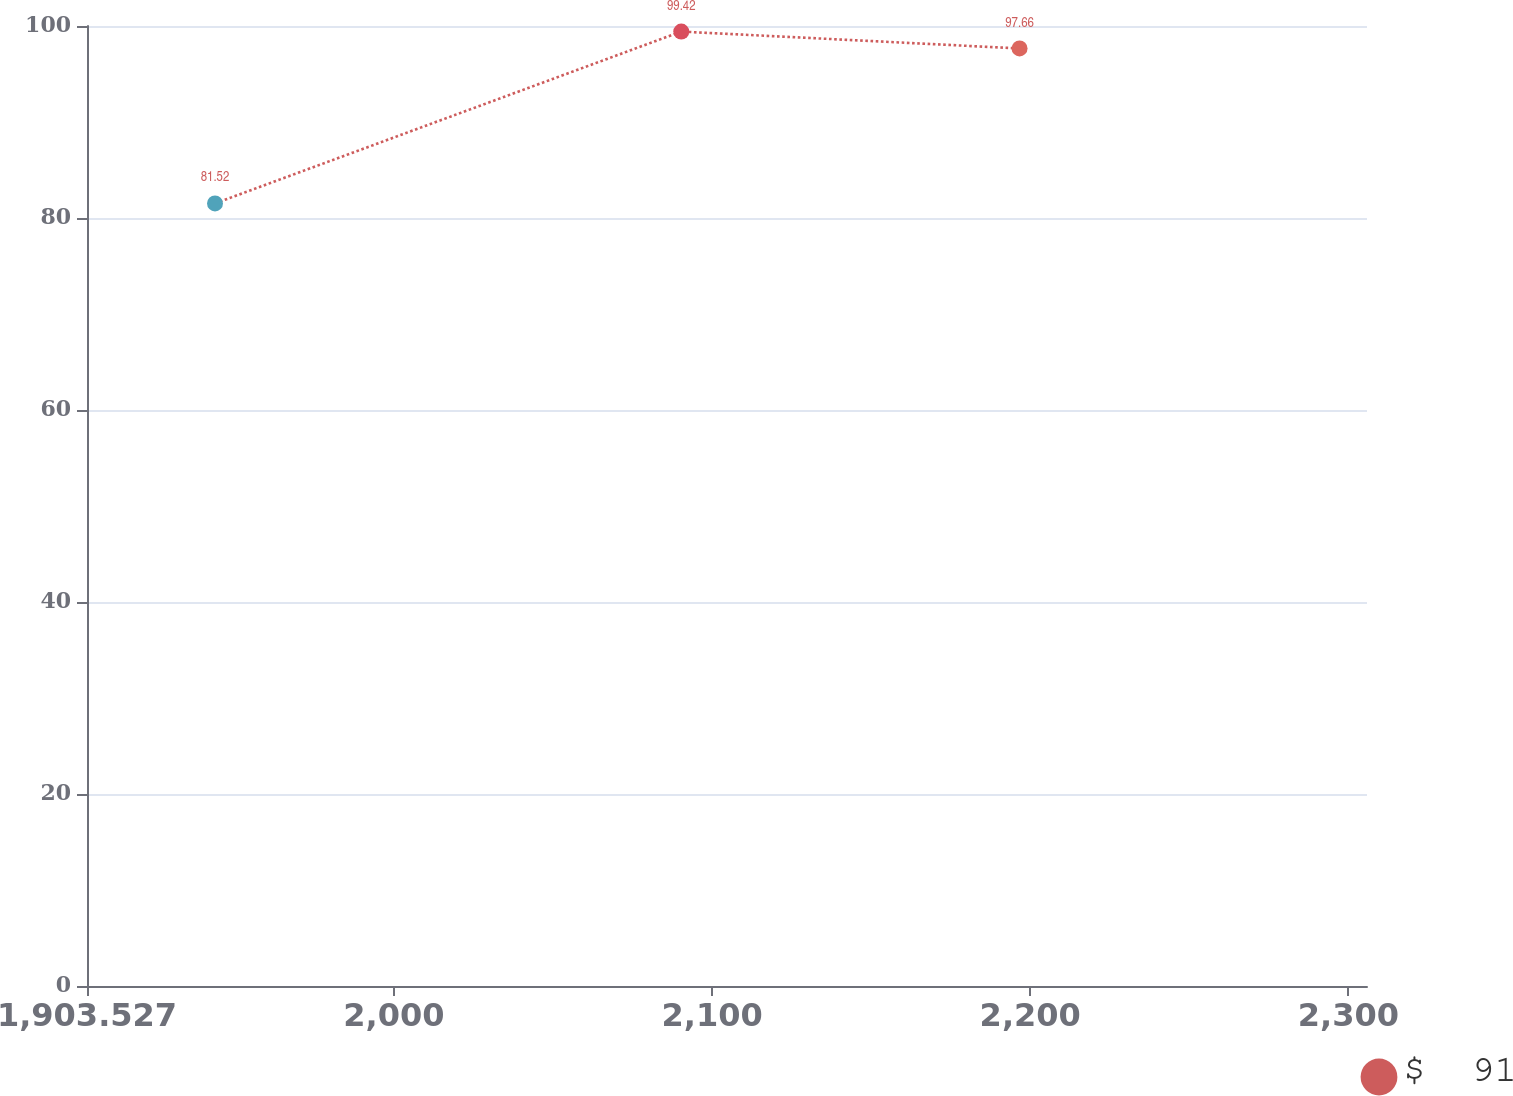Convert chart. <chart><loc_0><loc_0><loc_500><loc_500><line_chart><ecel><fcel>$  91<nl><fcel>1943.76<fcel>81.52<nl><fcel>2090.32<fcel>99.42<nl><fcel>2196.65<fcel>97.66<nl><fcel>2346.09<fcel>92.26<nl></chart> 